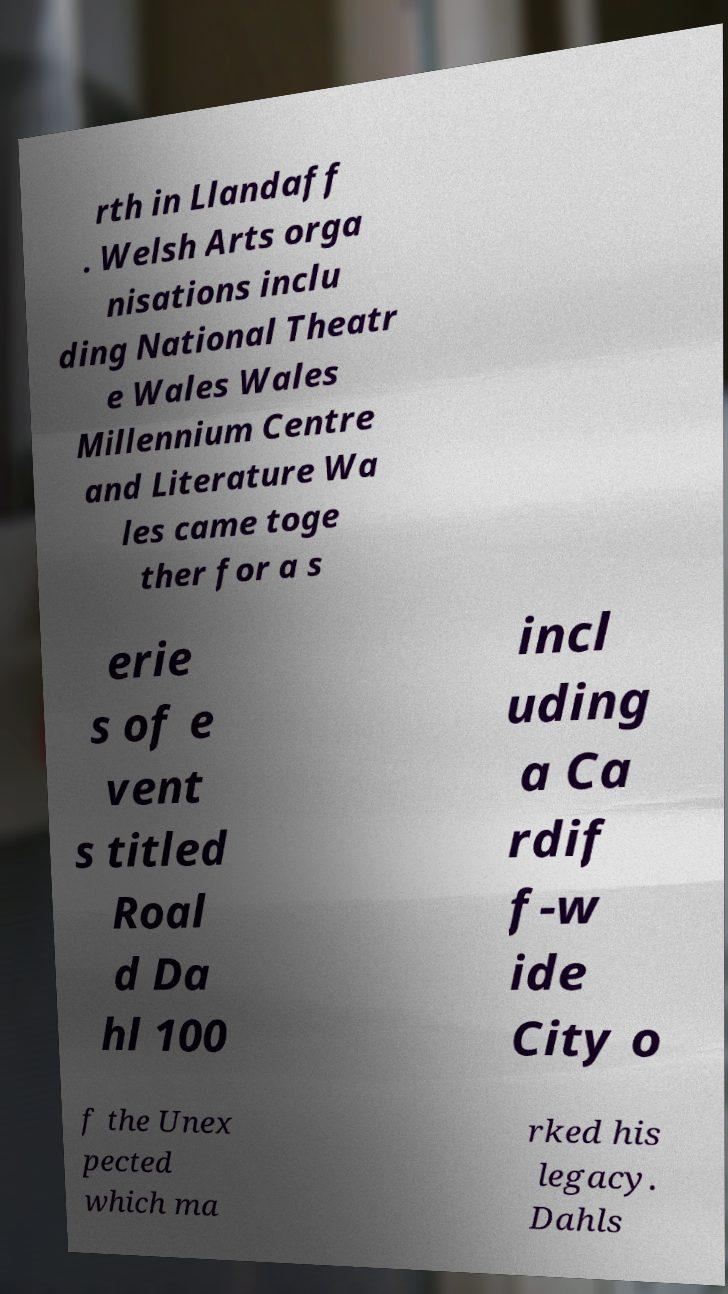Please read and relay the text visible in this image. What does it say? rth in Llandaff . Welsh Arts orga nisations inclu ding National Theatr e Wales Wales Millennium Centre and Literature Wa les came toge ther for a s erie s of e vent s titled Roal d Da hl 100 incl uding a Ca rdif f-w ide City o f the Unex pected which ma rked his legacy. Dahls 